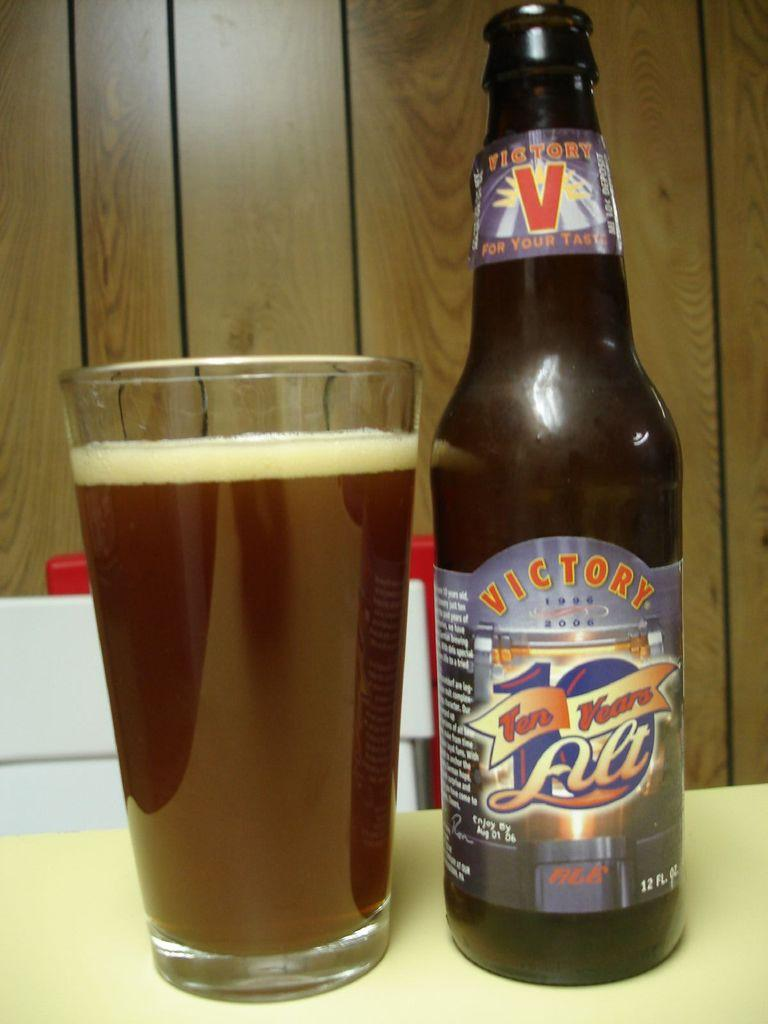<image>
Create a compact narrative representing the image presented. A bottle of Victory ale is next to a full glass. 